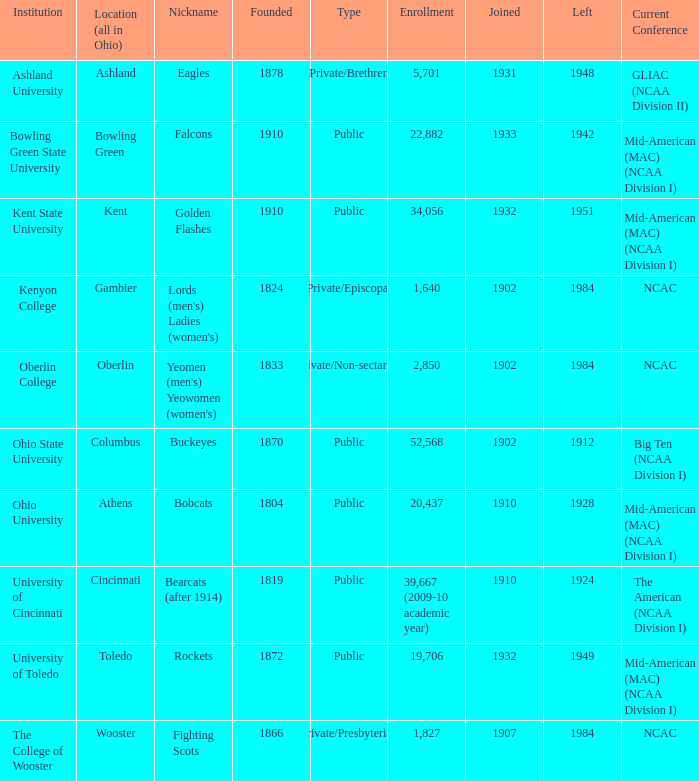Which year did enrolled Gambier members leave? 1984.0. 